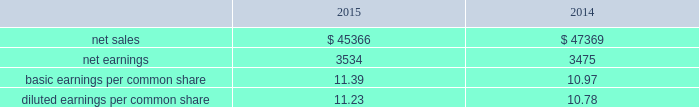The income approach indicates value for an asset or liability based on the present value of cash flow projected to be generated over the remaining economic life of the asset or liability being measured .
Both the amount and the duration of the cash flows are considered from a market participant perspective .
Our estimates of market participant net cash flows considered historical and projected pricing , remaining developmental effort , operational performance including company- specific synergies , aftermarket retention , product life cycles , material and labor pricing , and other relevant customer , contractual and market factors .
Where appropriate , the net cash flows are adjusted to reflect the uncertainties associated with the underlying assumptions , as well as the risk profile of the net cash flows utilized in the valuation .
The adjusted future cash flows are then discounted to present value using an appropriate discount rate .
Projected cash flow is discounted at a required rate of return that reflects the relative risk of achieving the cash flows and the time value of money .
The market approach is a valuation technique that uses prices and other relevant information generated by market transactions involving identical or comparable assets , liabilities , or a group of assets and liabilities .
Valuation techniques consistent with the market approach often use market multiples derived from a set of comparables .
The cost approach , which estimates value by determining the current cost of replacing an asset with another of equivalent economic utility , was used , as appropriate , for property , plant and equipment .
The cost to replace a given asset reflects the estimated reproduction or replacement cost , less an allowance for loss in value due to depreciation .
The purchase price allocation resulted in the recognition of $ 2.8 billion of goodwill , all of which is expected to be amortizable for tax purposes .
Substantially all of the goodwill was assigned to our rms business .
The goodwill recognized is attributable to expected revenue synergies generated by the integration of our products and technologies with those of sikorsky , costs synergies resulting from the consolidation or elimination of certain functions , and intangible assets that do not qualify for separate recognition , such as the assembled workforce of sikorsky .
Determining the fair value of assets acquired and liabilities assumed requires the exercise of significant judgments , including the amount and timing of expected future cash flows , long-term growth rates and discount rates .
The cash flows employed in the dcf analyses are based on our best estimate of future sales , earnings and cash flows after considering factors such as general market conditions , customer budgets , existing firm orders , expected future orders , contracts with suppliers , labor agreements , changes in working capital , long term business plans and recent operating performance .
Use of different estimates and judgments could yield different results .
Impact to 2015 financial results sikorsky 2019s 2015 financial results have been included in our consolidated financial results only for the period from the november 6 , 2015 acquisition date through december 31 , 2015 .
As a result , our consolidated financial results for the year ended december 31 , 2015 do not reflect a full year of sikorsky 2019s results .
From the november 6 , 2015 acquisition date through december 31 , 2015 , sikorsky generated net sales of approximately $ 400 million and operating loss of approximately $ 45 million , inclusive of intangible amortization and adjustments required to account for the acquisition .
We incurred approximately $ 38 million of non-recoverable transaction costs associated with the sikorsky acquisition in 2015 that were expensed as incurred .
These costs are included in other income , net on our consolidated statements of earnings .
We also incurred approximately $ 48 million in costs associated with issuing the $ 7.0 billion november 2015 notes used to repay all outstanding borrowings under the 364-day facility used to finance the acquisition .
The financing costs were recorded as a reduction of debt and will be amortized to interest expense over the term of the related debt .
Supplemental pro forma financial information ( unaudited ) the table presents summarized unaudited pro forma financial information as if sikorsky had been included in our financial results for the entire years in 2015 and 2014 ( in millions ) : .
The unaudited supplemental pro forma financial data above has been calculated after applying our accounting policies and adjusting the historical results of sikorsky with pro forma adjustments , net of tax , that assume the acquisition occurred on january 1 , 2014 .
Significant pro forma adjustments include the recognition of additional amortization expense related to acquired intangible assets and additional interest expense related to the short-term debt used to finance the acquisition .
These .
What was the percentage change in net sales from 2014 to 2015 for the pro forma financials? 
Computations: ((45366 - 47369) / 47369)
Answer: -0.04229. 